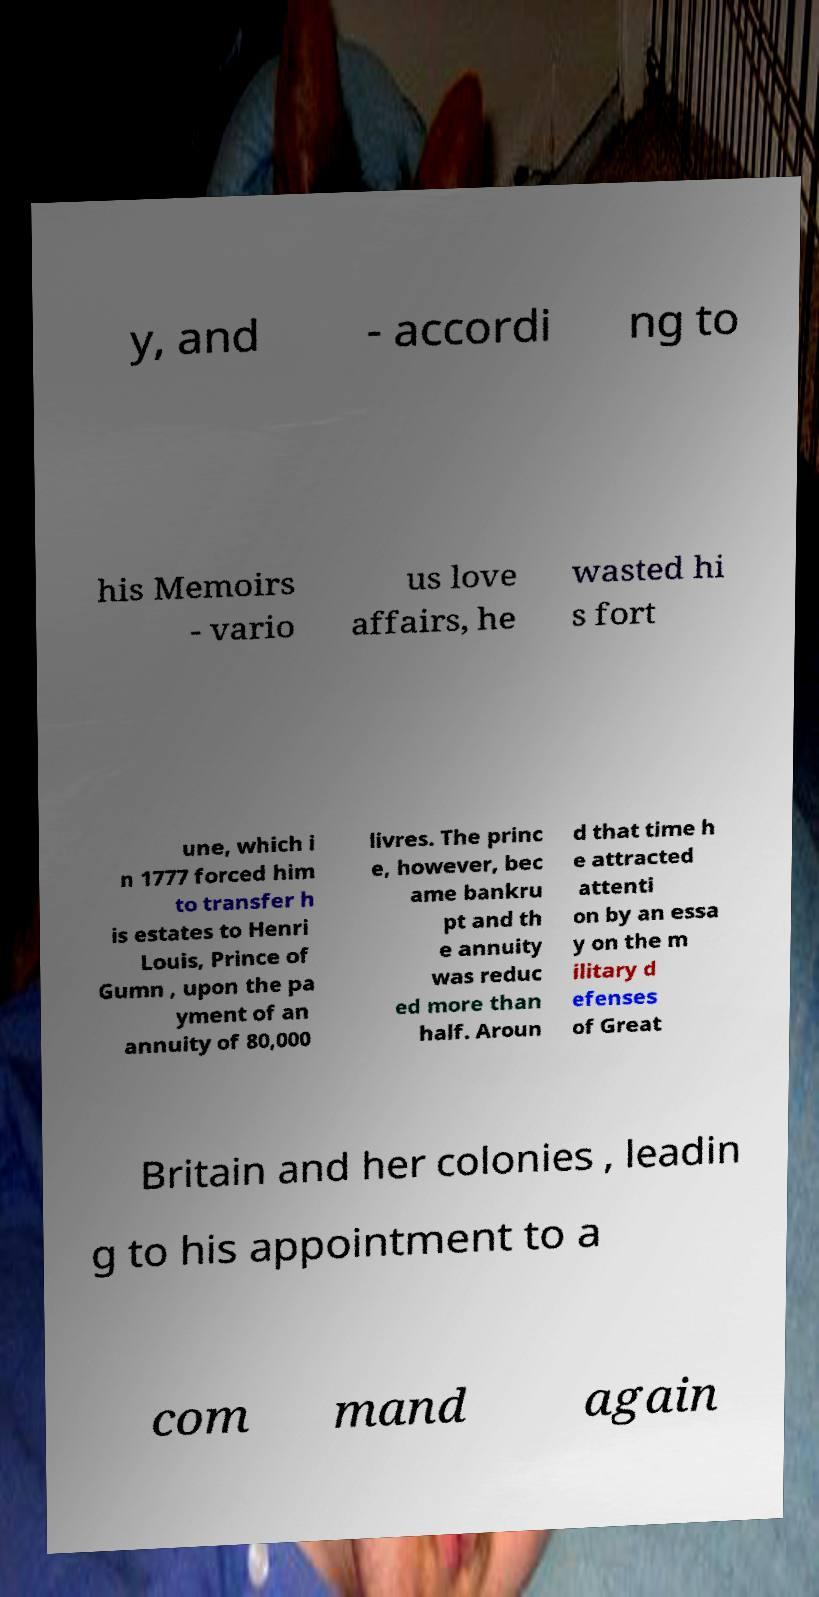Please identify and transcribe the text found in this image. y, and - accordi ng to his Memoirs - vario us love affairs, he wasted hi s fort une, which i n 1777 forced him to transfer h is estates to Henri Louis, Prince of Gumn , upon the pa yment of an annuity of 80,000 livres. The princ e, however, bec ame bankru pt and th e annuity was reduc ed more than half. Aroun d that time h e attracted attenti on by an essa y on the m ilitary d efenses of Great Britain and her colonies , leadin g to his appointment to a com mand again 